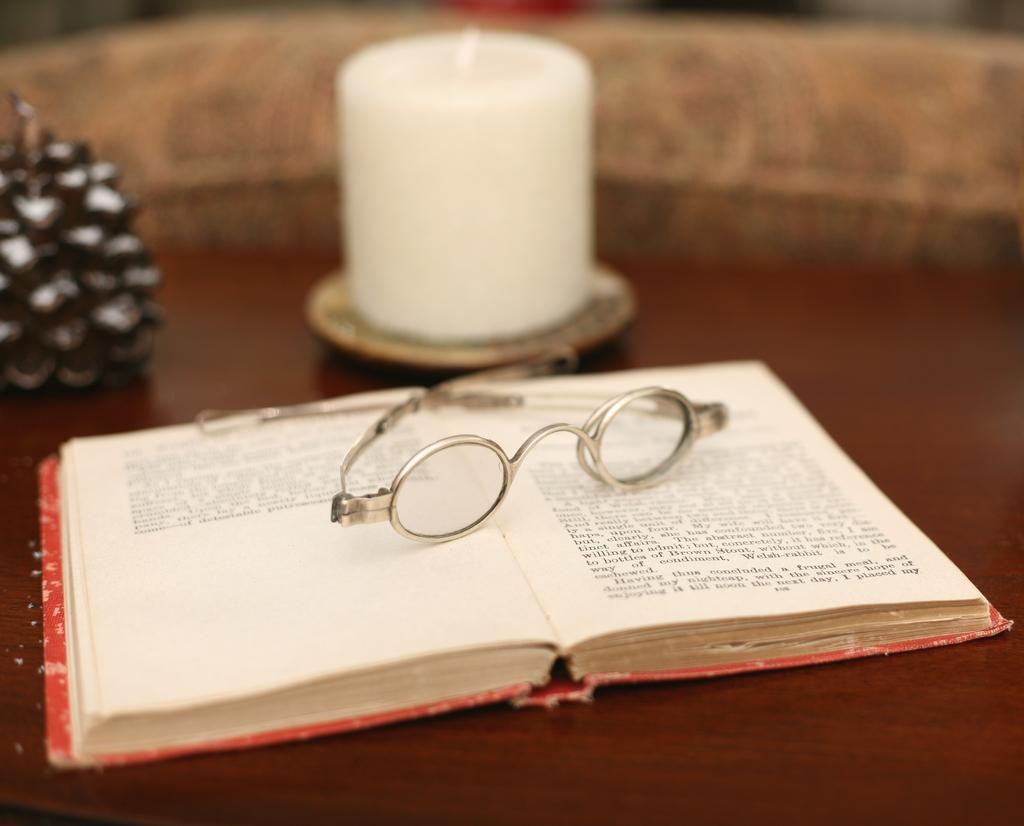In one or two sentences, can you explain what this image depicts? In this image I can see specs on a book, candle and some object may be on a table. This image is taken may be in a hall. 